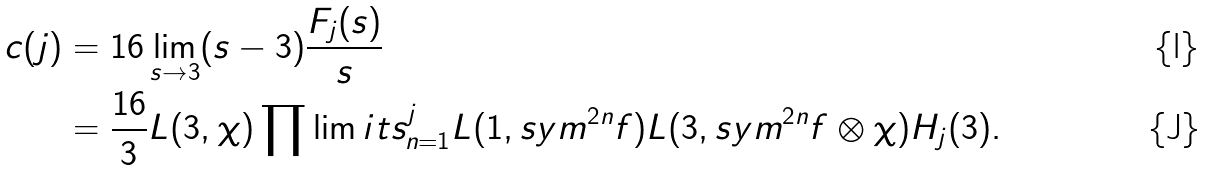Convert formula to latex. <formula><loc_0><loc_0><loc_500><loc_500>c ( j ) & = 1 6 \lim _ { s \to 3 } ( s - 3 ) \frac { F _ { j } ( s ) } { s } \\ & = \frac { 1 6 } { 3 } L ( 3 , \chi ) \prod \lim i t s _ { n = 1 } ^ { j } L ( 1 , s y m ^ { 2 n } f ) L ( 3 , s y m ^ { 2 n } f \otimes \chi ) H _ { j } ( 3 ) .</formula> 